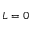<formula> <loc_0><loc_0><loc_500><loc_500>L = 0</formula> 